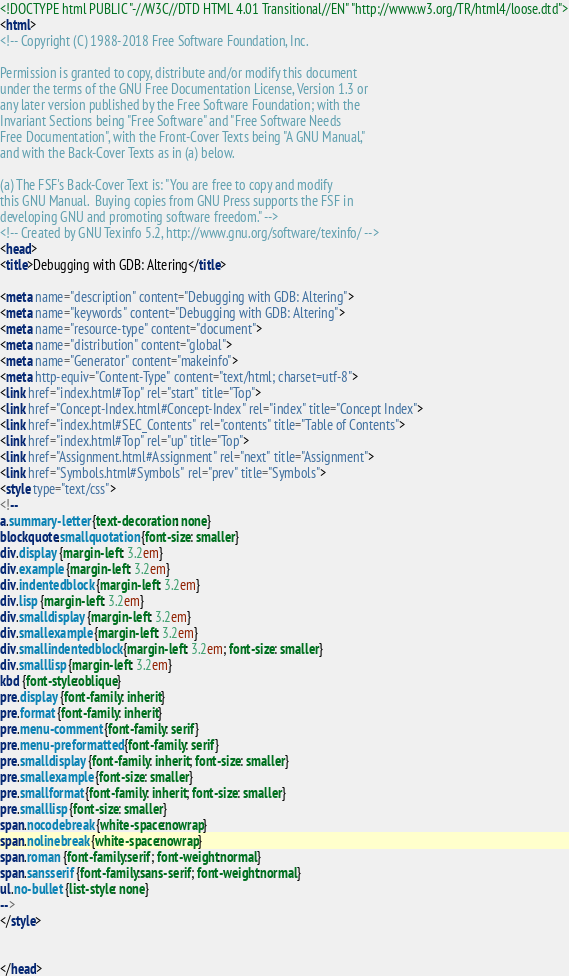Convert code to text. <code><loc_0><loc_0><loc_500><loc_500><_HTML_><!DOCTYPE html PUBLIC "-//W3C//DTD HTML 4.01 Transitional//EN" "http://www.w3.org/TR/html4/loose.dtd">
<html>
<!-- Copyright (C) 1988-2018 Free Software Foundation, Inc.

Permission is granted to copy, distribute and/or modify this document
under the terms of the GNU Free Documentation License, Version 1.3 or
any later version published by the Free Software Foundation; with the
Invariant Sections being "Free Software" and "Free Software Needs
Free Documentation", with the Front-Cover Texts being "A GNU Manual,"
and with the Back-Cover Texts as in (a) below.

(a) The FSF's Back-Cover Text is: "You are free to copy and modify
this GNU Manual.  Buying copies from GNU Press supports the FSF in
developing GNU and promoting software freedom." -->
<!-- Created by GNU Texinfo 5.2, http://www.gnu.org/software/texinfo/ -->
<head>
<title>Debugging with GDB: Altering</title>

<meta name="description" content="Debugging with GDB: Altering">
<meta name="keywords" content="Debugging with GDB: Altering">
<meta name="resource-type" content="document">
<meta name="distribution" content="global">
<meta name="Generator" content="makeinfo">
<meta http-equiv="Content-Type" content="text/html; charset=utf-8">
<link href="index.html#Top" rel="start" title="Top">
<link href="Concept-Index.html#Concept-Index" rel="index" title="Concept Index">
<link href="index.html#SEC_Contents" rel="contents" title="Table of Contents">
<link href="index.html#Top" rel="up" title="Top">
<link href="Assignment.html#Assignment" rel="next" title="Assignment">
<link href="Symbols.html#Symbols" rel="prev" title="Symbols">
<style type="text/css">
<!--
a.summary-letter {text-decoration: none}
blockquote.smallquotation {font-size: smaller}
div.display {margin-left: 3.2em}
div.example {margin-left: 3.2em}
div.indentedblock {margin-left: 3.2em}
div.lisp {margin-left: 3.2em}
div.smalldisplay {margin-left: 3.2em}
div.smallexample {margin-left: 3.2em}
div.smallindentedblock {margin-left: 3.2em; font-size: smaller}
div.smalllisp {margin-left: 3.2em}
kbd {font-style:oblique}
pre.display {font-family: inherit}
pre.format {font-family: inherit}
pre.menu-comment {font-family: serif}
pre.menu-preformatted {font-family: serif}
pre.smalldisplay {font-family: inherit; font-size: smaller}
pre.smallexample {font-size: smaller}
pre.smallformat {font-family: inherit; font-size: smaller}
pre.smalllisp {font-size: smaller}
span.nocodebreak {white-space:nowrap}
span.nolinebreak {white-space:nowrap}
span.roman {font-family:serif; font-weight:normal}
span.sansserif {font-family:sans-serif; font-weight:normal}
ul.no-bullet {list-style: none}
-->
</style>


</head>
</code> 